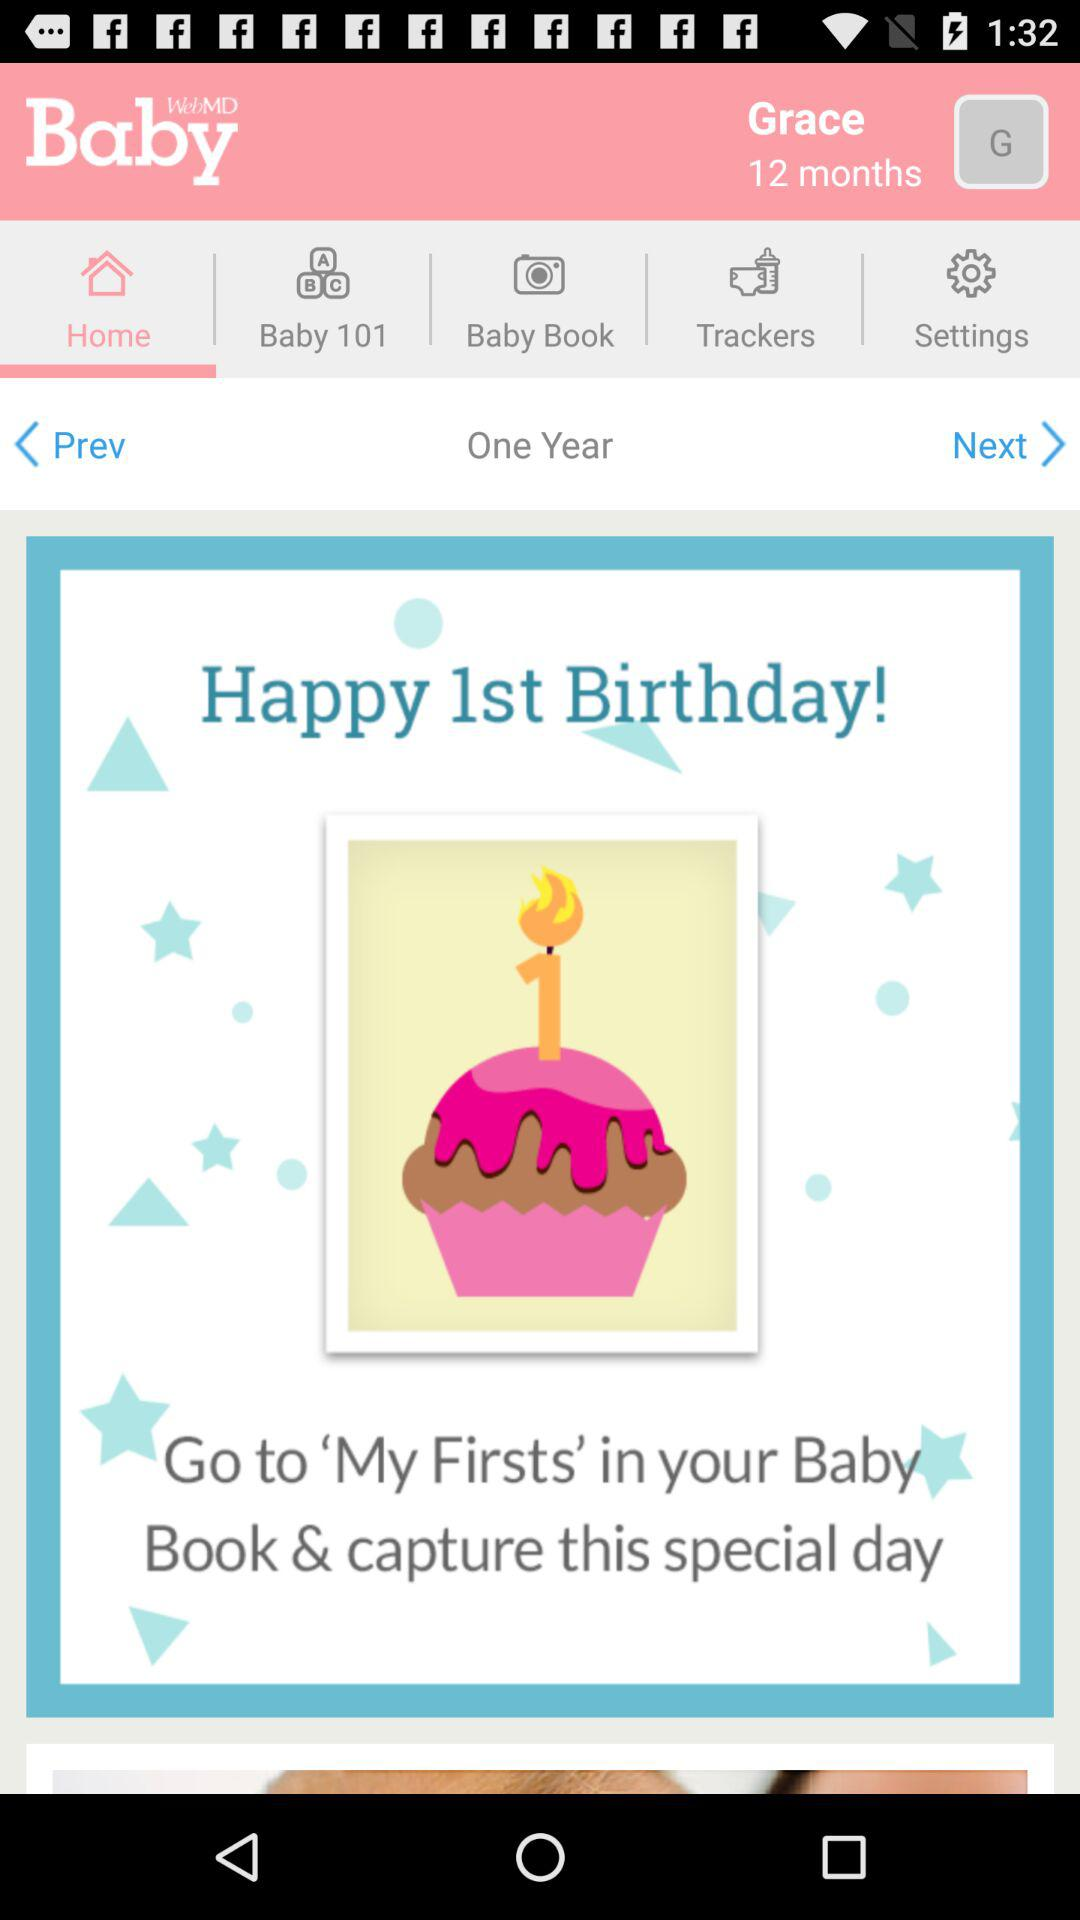What is the name of the application? The name of the application is "WebMD Baby". 